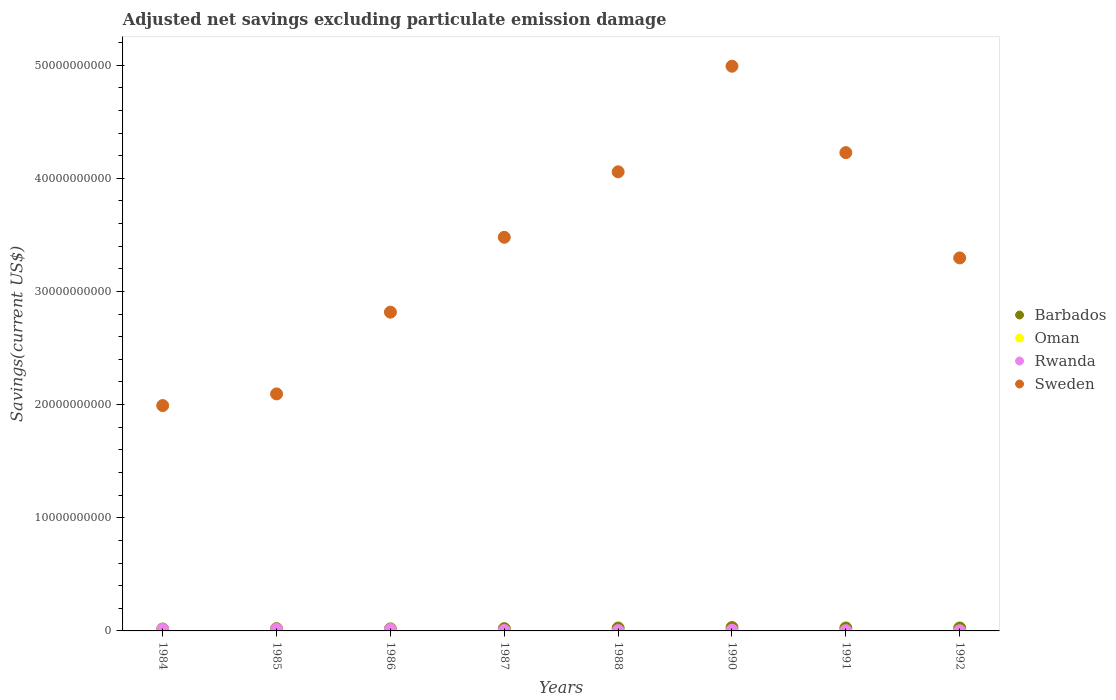How many different coloured dotlines are there?
Your answer should be compact. 4. Is the number of dotlines equal to the number of legend labels?
Offer a terse response. No. What is the adjusted net savings in Barbados in 1990?
Keep it short and to the point. 2.99e+08. Across all years, what is the maximum adjusted net savings in Oman?
Give a very brief answer. 1.23e+06. Across all years, what is the minimum adjusted net savings in Barbados?
Offer a terse response. 1.71e+08. What is the total adjusted net savings in Sweden in the graph?
Your answer should be compact. 2.70e+11. What is the difference between the adjusted net savings in Barbados in 1984 and that in 1991?
Offer a terse response. -9.13e+07. What is the difference between the adjusted net savings in Sweden in 1988 and the adjusted net savings in Rwanda in 1987?
Offer a very short reply. 4.05e+1. What is the average adjusted net savings in Oman per year?
Make the answer very short. 1.54e+05. In the year 1986, what is the difference between the adjusted net savings in Barbados and adjusted net savings in Rwanda?
Offer a terse response. 5.23e+07. In how many years, is the adjusted net savings in Oman greater than 32000000000 US$?
Provide a succinct answer. 0. What is the ratio of the adjusted net savings in Rwanda in 1987 to that in 1992?
Make the answer very short. 2.24. Is the adjusted net savings in Barbados in 1990 less than that in 1992?
Provide a short and direct response. No. Is the difference between the adjusted net savings in Barbados in 1984 and 1992 greater than the difference between the adjusted net savings in Rwanda in 1984 and 1992?
Keep it short and to the point. No. What is the difference between the highest and the second highest adjusted net savings in Barbados?
Your response must be concise. 3.71e+07. What is the difference between the highest and the lowest adjusted net savings in Sweden?
Your response must be concise. 3.00e+1. Is the sum of the adjusted net savings in Barbados in 1984 and 1985 greater than the maximum adjusted net savings in Oman across all years?
Give a very brief answer. Yes. Does the adjusted net savings in Sweden monotonically increase over the years?
Make the answer very short. No. Is the adjusted net savings in Oman strictly less than the adjusted net savings in Rwanda over the years?
Provide a succinct answer. Yes. What is the difference between two consecutive major ticks on the Y-axis?
Offer a terse response. 1.00e+1. Does the graph contain any zero values?
Make the answer very short. Yes. Does the graph contain grids?
Make the answer very short. No. How are the legend labels stacked?
Provide a succinct answer. Vertical. What is the title of the graph?
Provide a succinct answer. Adjusted net savings excluding particulate emission damage. What is the label or title of the X-axis?
Ensure brevity in your answer.  Years. What is the label or title of the Y-axis?
Your response must be concise. Savings(current US$). What is the Savings(current US$) in Barbados in 1984?
Give a very brief answer. 1.71e+08. What is the Savings(current US$) in Oman in 1984?
Provide a succinct answer. 1.23e+06. What is the Savings(current US$) in Rwanda in 1984?
Offer a very short reply. 1.42e+08. What is the Savings(current US$) in Sweden in 1984?
Your response must be concise. 1.99e+1. What is the Savings(current US$) in Barbados in 1985?
Ensure brevity in your answer.  2.02e+08. What is the Savings(current US$) in Rwanda in 1985?
Offer a terse response. 1.50e+08. What is the Savings(current US$) of Sweden in 1985?
Your response must be concise. 2.09e+1. What is the Savings(current US$) in Barbados in 1986?
Offer a terse response. 1.79e+08. What is the Savings(current US$) in Oman in 1986?
Your answer should be very brief. 0. What is the Savings(current US$) of Rwanda in 1986?
Your answer should be compact. 1.27e+08. What is the Savings(current US$) of Sweden in 1986?
Your answer should be very brief. 2.82e+1. What is the Savings(current US$) in Barbados in 1987?
Make the answer very short. 2.01e+08. What is the Savings(current US$) of Rwanda in 1987?
Offer a terse response. 3.83e+07. What is the Savings(current US$) of Sweden in 1987?
Make the answer very short. 3.48e+1. What is the Savings(current US$) in Barbados in 1988?
Your response must be concise. 2.58e+08. What is the Savings(current US$) in Oman in 1988?
Offer a terse response. 0. What is the Savings(current US$) of Rwanda in 1988?
Your response must be concise. 2.87e+07. What is the Savings(current US$) of Sweden in 1988?
Offer a very short reply. 4.06e+1. What is the Savings(current US$) in Barbados in 1990?
Provide a short and direct response. 2.99e+08. What is the Savings(current US$) in Rwanda in 1990?
Ensure brevity in your answer.  6.31e+07. What is the Savings(current US$) of Sweden in 1990?
Make the answer very short. 4.99e+1. What is the Savings(current US$) of Barbados in 1991?
Provide a succinct answer. 2.62e+08. What is the Savings(current US$) in Rwanda in 1991?
Offer a very short reply. 2.37e+07. What is the Savings(current US$) in Sweden in 1991?
Offer a terse response. 4.23e+1. What is the Savings(current US$) in Barbados in 1992?
Make the answer very short. 2.60e+08. What is the Savings(current US$) in Rwanda in 1992?
Offer a very short reply. 1.71e+07. What is the Savings(current US$) in Sweden in 1992?
Give a very brief answer. 3.30e+1. Across all years, what is the maximum Savings(current US$) of Barbados?
Offer a terse response. 2.99e+08. Across all years, what is the maximum Savings(current US$) in Oman?
Your response must be concise. 1.23e+06. Across all years, what is the maximum Savings(current US$) in Rwanda?
Ensure brevity in your answer.  1.50e+08. Across all years, what is the maximum Savings(current US$) in Sweden?
Ensure brevity in your answer.  4.99e+1. Across all years, what is the minimum Savings(current US$) in Barbados?
Ensure brevity in your answer.  1.71e+08. Across all years, what is the minimum Savings(current US$) of Oman?
Offer a very short reply. 0. Across all years, what is the minimum Savings(current US$) of Rwanda?
Your answer should be compact. 1.71e+07. Across all years, what is the minimum Savings(current US$) in Sweden?
Provide a succinct answer. 1.99e+1. What is the total Savings(current US$) of Barbados in the graph?
Make the answer very short. 1.83e+09. What is the total Savings(current US$) of Oman in the graph?
Your answer should be compact. 1.23e+06. What is the total Savings(current US$) in Rwanda in the graph?
Offer a terse response. 5.89e+08. What is the total Savings(current US$) in Sweden in the graph?
Keep it short and to the point. 2.70e+11. What is the difference between the Savings(current US$) of Barbados in 1984 and that in 1985?
Your answer should be compact. -3.12e+07. What is the difference between the Savings(current US$) of Rwanda in 1984 and that in 1985?
Offer a terse response. -7.88e+06. What is the difference between the Savings(current US$) of Sweden in 1984 and that in 1985?
Keep it short and to the point. -1.03e+09. What is the difference between the Savings(current US$) in Barbados in 1984 and that in 1986?
Offer a terse response. -8.00e+06. What is the difference between the Savings(current US$) in Rwanda in 1984 and that in 1986?
Give a very brief answer. 1.51e+07. What is the difference between the Savings(current US$) in Sweden in 1984 and that in 1986?
Your answer should be compact. -8.25e+09. What is the difference between the Savings(current US$) of Barbados in 1984 and that in 1987?
Your answer should be very brief. -2.98e+07. What is the difference between the Savings(current US$) in Rwanda in 1984 and that in 1987?
Give a very brief answer. 1.03e+08. What is the difference between the Savings(current US$) in Sweden in 1984 and that in 1987?
Your answer should be very brief. -1.49e+1. What is the difference between the Savings(current US$) of Barbados in 1984 and that in 1988?
Offer a very short reply. -8.71e+07. What is the difference between the Savings(current US$) in Rwanda in 1984 and that in 1988?
Ensure brevity in your answer.  1.13e+08. What is the difference between the Savings(current US$) in Sweden in 1984 and that in 1988?
Provide a succinct answer. -2.07e+1. What is the difference between the Savings(current US$) of Barbados in 1984 and that in 1990?
Your response must be concise. -1.28e+08. What is the difference between the Savings(current US$) of Rwanda in 1984 and that in 1990?
Give a very brief answer. 7.86e+07. What is the difference between the Savings(current US$) of Sweden in 1984 and that in 1990?
Provide a succinct answer. -3.00e+1. What is the difference between the Savings(current US$) of Barbados in 1984 and that in 1991?
Ensure brevity in your answer.  -9.13e+07. What is the difference between the Savings(current US$) of Rwanda in 1984 and that in 1991?
Your answer should be compact. 1.18e+08. What is the difference between the Savings(current US$) of Sweden in 1984 and that in 1991?
Your response must be concise. -2.24e+1. What is the difference between the Savings(current US$) in Barbados in 1984 and that in 1992?
Offer a terse response. -8.94e+07. What is the difference between the Savings(current US$) in Rwanda in 1984 and that in 1992?
Ensure brevity in your answer.  1.25e+08. What is the difference between the Savings(current US$) in Sweden in 1984 and that in 1992?
Ensure brevity in your answer.  -1.30e+1. What is the difference between the Savings(current US$) in Barbados in 1985 and that in 1986?
Offer a terse response. 2.32e+07. What is the difference between the Savings(current US$) in Rwanda in 1985 and that in 1986?
Ensure brevity in your answer.  2.30e+07. What is the difference between the Savings(current US$) in Sweden in 1985 and that in 1986?
Make the answer very short. -7.22e+09. What is the difference between the Savings(current US$) in Barbados in 1985 and that in 1987?
Ensure brevity in your answer.  1.39e+06. What is the difference between the Savings(current US$) in Rwanda in 1985 and that in 1987?
Provide a succinct answer. 1.11e+08. What is the difference between the Savings(current US$) of Sweden in 1985 and that in 1987?
Give a very brief answer. -1.38e+1. What is the difference between the Savings(current US$) in Barbados in 1985 and that in 1988?
Make the answer very short. -5.59e+07. What is the difference between the Savings(current US$) of Rwanda in 1985 and that in 1988?
Offer a terse response. 1.21e+08. What is the difference between the Savings(current US$) in Sweden in 1985 and that in 1988?
Your response must be concise. -1.96e+1. What is the difference between the Savings(current US$) in Barbados in 1985 and that in 1990?
Ensure brevity in your answer.  -9.72e+07. What is the difference between the Savings(current US$) of Rwanda in 1985 and that in 1990?
Provide a succinct answer. 8.65e+07. What is the difference between the Savings(current US$) in Sweden in 1985 and that in 1990?
Offer a terse response. -2.90e+1. What is the difference between the Savings(current US$) in Barbados in 1985 and that in 1991?
Make the answer very short. -6.01e+07. What is the difference between the Savings(current US$) in Rwanda in 1985 and that in 1991?
Keep it short and to the point. 1.26e+08. What is the difference between the Savings(current US$) in Sweden in 1985 and that in 1991?
Your answer should be very brief. -2.13e+1. What is the difference between the Savings(current US$) of Barbados in 1985 and that in 1992?
Offer a very short reply. -5.82e+07. What is the difference between the Savings(current US$) in Rwanda in 1985 and that in 1992?
Make the answer very short. 1.33e+08. What is the difference between the Savings(current US$) of Sweden in 1985 and that in 1992?
Ensure brevity in your answer.  -1.20e+1. What is the difference between the Savings(current US$) of Barbados in 1986 and that in 1987?
Ensure brevity in your answer.  -2.18e+07. What is the difference between the Savings(current US$) in Rwanda in 1986 and that in 1987?
Provide a succinct answer. 8.84e+07. What is the difference between the Savings(current US$) in Sweden in 1986 and that in 1987?
Your answer should be very brief. -6.62e+09. What is the difference between the Savings(current US$) of Barbados in 1986 and that in 1988?
Offer a very short reply. -7.91e+07. What is the difference between the Savings(current US$) of Rwanda in 1986 and that in 1988?
Your answer should be compact. 9.80e+07. What is the difference between the Savings(current US$) of Sweden in 1986 and that in 1988?
Offer a terse response. -1.24e+1. What is the difference between the Savings(current US$) of Barbados in 1986 and that in 1990?
Provide a succinct answer. -1.20e+08. What is the difference between the Savings(current US$) in Rwanda in 1986 and that in 1990?
Provide a succinct answer. 6.35e+07. What is the difference between the Savings(current US$) of Sweden in 1986 and that in 1990?
Your answer should be very brief. -2.17e+1. What is the difference between the Savings(current US$) of Barbados in 1986 and that in 1991?
Ensure brevity in your answer.  -8.33e+07. What is the difference between the Savings(current US$) of Rwanda in 1986 and that in 1991?
Provide a short and direct response. 1.03e+08. What is the difference between the Savings(current US$) of Sweden in 1986 and that in 1991?
Offer a terse response. -1.41e+1. What is the difference between the Savings(current US$) of Barbados in 1986 and that in 1992?
Your answer should be very brief. -8.14e+07. What is the difference between the Savings(current US$) of Rwanda in 1986 and that in 1992?
Your answer should be very brief. 1.10e+08. What is the difference between the Savings(current US$) of Sweden in 1986 and that in 1992?
Offer a very short reply. -4.79e+09. What is the difference between the Savings(current US$) of Barbados in 1987 and that in 1988?
Offer a terse response. -5.73e+07. What is the difference between the Savings(current US$) of Rwanda in 1987 and that in 1988?
Offer a terse response. 9.61e+06. What is the difference between the Savings(current US$) of Sweden in 1987 and that in 1988?
Your answer should be very brief. -5.79e+09. What is the difference between the Savings(current US$) of Barbados in 1987 and that in 1990?
Your response must be concise. -9.86e+07. What is the difference between the Savings(current US$) of Rwanda in 1987 and that in 1990?
Keep it short and to the point. -2.48e+07. What is the difference between the Savings(current US$) of Sweden in 1987 and that in 1990?
Your answer should be very brief. -1.51e+1. What is the difference between the Savings(current US$) of Barbados in 1987 and that in 1991?
Your answer should be very brief. -6.15e+07. What is the difference between the Savings(current US$) in Rwanda in 1987 and that in 1991?
Your response must be concise. 1.46e+07. What is the difference between the Savings(current US$) of Sweden in 1987 and that in 1991?
Offer a very short reply. -7.48e+09. What is the difference between the Savings(current US$) in Barbados in 1987 and that in 1992?
Your answer should be compact. -5.96e+07. What is the difference between the Savings(current US$) of Rwanda in 1987 and that in 1992?
Your answer should be very brief. 2.12e+07. What is the difference between the Savings(current US$) in Sweden in 1987 and that in 1992?
Give a very brief answer. 1.82e+09. What is the difference between the Savings(current US$) of Barbados in 1988 and that in 1990?
Your answer should be compact. -4.13e+07. What is the difference between the Savings(current US$) of Rwanda in 1988 and that in 1990?
Make the answer very short. -3.45e+07. What is the difference between the Savings(current US$) in Sweden in 1988 and that in 1990?
Keep it short and to the point. -9.33e+09. What is the difference between the Savings(current US$) in Barbados in 1988 and that in 1991?
Your answer should be very brief. -4.21e+06. What is the difference between the Savings(current US$) in Rwanda in 1988 and that in 1991?
Provide a succinct answer. 5.02e+06. What is the difference between the Savings(current US$) in Sweden in 1988 and that in 1991?
Offer a very short reply. -1.70e+09. What is the difference between the Savings(current US$) in Barbados in 1988 and that in 1992?
Make the answer very short. -2.31e+06. What is the difference between the Savings(current US$) of Rwanda in 1988 and that in 1992?
Offer a very short reply. 1.16e+07. What is the difference between the Savings(current US$) in Sweden in 1988 and that in 1992?
Your answer should be very brief. 7.61e+09. What is the difference between the Savings(current US$) of Barbados in 1990 and that in 1991?
Make the answer very short. 3.71e+07. What is the difference between the Savings(current US$) of Rwanda in 1990 and that in 1991?
Your answer should be very brief. 3.95e+07. What is the difference between the Savings(current US$) of Sweden in 1990 and that in 1991?
Your response must be concise. 7.64e+09. What is the difference between the Savings(current US$) of Barbados in 1990 and that in 1992?
Your response must be concise. 3.90e+07. What is the difference between the Savings(current US$) of Rwanda in 1990 and that in 1992?
Provide a succinct answer. 4.60e+07. What is the difference between the Savings(current US$) in Sweden in 1990 and that in 1992?
Keep it short and to the point. 1.69e+1. What is the difference between the Savings(current US$) of Barbados in 1991 and that in 1992?
Offer a very short reply. 1.89e+06. What is the difference between the Savings(current US$) of Rwanda in 1991 and that in 1992?
Provide a short and direct response. 6.56e+06. What is the difference between the Savings(current US$) of Sweden in 1991 and that in 1992?
Give a very brief answer. 9.31e+09. What is the difference between the Savings(current US$) of Barbados in 1984 and the Savings(current US$) of Rwanda in 1985?
Provide a short and direct response. 2.13e+07. What is the difference between the Savings(current US$) in Barbados in 1984 and the Savings(current US$) in Sweden in 1985?
Your response must be concise. -2.08e+1. What is the difference between the Savings(current US$) of Oman in 1984 and the Savings(current US$) of Rwanda in 1985?
Make the answer very short. -1.48e+08. What is the difference between the Savings(current US$) in Oman in 1984 and the Savings(current US$) in Sweden in 1985?
Give a very brief answer. -2.09e+1. What is the difference between the Savings(current US$) of Rwanda in 1984 and the Savings(current US$) of Sweden in 1985?
Offer a very short reply. -2.08e+1. What is the difference between the Savings(current US$) of Barbados in 1984 and the Savings(current US$) of Rwanda in 1986?
Your answer should be compact. 4.43e+07. What is the difference between the Savings(current US$) of Barbados in 1984 and the Savings(current US$) of Sweden in 1986?
Your answer should be very brief. -2.80e+1. What is the difference between the Savings(current US$) in Oman in 1984 and the Savings(current US$) in Rwanda in 1986?
Ensure brevity in your answer.  -1.25e+08. What is the difference between the Savings(current US$) of Oman in 1984 and the Savings(current US$) of Sweden in 1986?
Offer a terse response. -2.82e+1. What is the difference between the Savings(current US$) of Rwanda in 1984 and the Savings(current US$) of Sweden in 1986?
Keep it short and to the point. -2.80e+1. What is the difference between the Savings(current US$) of Barbados in 1984 and the Savings(current US$) of Rwanda in 1987?
Provide a succinct answer. 1.33e+08. What is the difference between the Savings(current US$) in Barbados in 1984 and the Savings(current US$) in Sweden in 1987?
Give a very brief answer. -3.46e+1. What is the difference between the Savings(current US$) of Oman in 1984 and the Savings(current US$) of Rwanda in 1987?
Your answer should be compact. -3.71e+07. What is the difference between the Savings(current US$) of Oman in 1984 and the Savings(current US$) of Sweden in 1987?
Give a very brief answer. -3.48e+1. What is the difference between the Savings(current US$) in Rwanda in 1984 and the Savings(current US$) in Sweden in 1987?
Offer a terse response. -3.46e+1. What is the difference between the Savings(current US$) of Barbados in 1984 and the Savings(current US$) of Rwanda in 1988?
Your answer should be very brief. 1.42e+08. What is the difference between the Savings(current US$) in Barbados in 1984 and the Savings(current US$) in Sweden in 1988?
Ensure brevity in your answer.  -4.04e+1. What is the difference between the Savings(current US$) in Oman in 1984 and the Savings(current US$) in Rwanda in 1988?
Provide a succinct answer. -2.75e+07. What is the difference between the Savings(current US$) in Oman in 1984 and the Savings(current US$) in Sweden in 1988?
Your response must be concise. -4.06e+1. What is the difference between the Savings(current US$) in Rwanda in 1984 and the Savings(current US$) in Sweden in 1988?
Keep it short and to the point. -4.04e+1. What is the difference between the Savings(current US$) in Barbados in 1984 and the Savings(current US$) in Rwanda in 1990?
Make the answer very short. 1.08e+08. What is the difference between the Savings(current US$) in Barbados in 1984 and the Savings(current US$) in Sweden in 1990?
Your answer should be very brief. -4.97e+1. What is the difference between the Savings(current US$) of Oman in 1984 and the Savings(current US$) of Rwanda in 1990?
Your answer should be compact. -6.19e+07. What is the difference between the Savings(current US$) in Oman in 1984 and the Savings(current US$) in Sweden in 1990?
Keep it short and to the point. -4.99e+1. What is the difference between the Savings(current US$) of Rwanda in 1984 and the Savings(current US$) of Sweden in 1990?
Offer a terse response. -4.98e+1. What is the difference between the Savings(current US$) in Barbados in 1984 and the Savings(current US$) in Rwanda in 1991?
Offer a very short reply. 1.47e+08. What is the difference between the Savings(current US$) of Barbados in 1984 and the Savings(current US$) of Sweden in 1991?
Offer a very short reply. -4.21e+1. What is the difference between the Savings(current US$) in Oman in 1984 and the Savings(current US$) in Rwanda in 1991?
Make the answer very short. -2.24e+07. What is the difference between the Savings(current US$) in Oman in 1984 and the Savings(current US$) in Sweden in 1991?
Offer a terse response. -4.23e+1. What is the difference between the Savings(current US$) in Rwanda in 1984 and the Savings(current US$) in Sweden in 1991?
Ensure brevity in your answer.  -4.21e+1. What is the difference between the Savings(current US$) in Barbados in 1984 and the Savings(current US$) in Rwanda in 1992?
Keep it short and to the point. 1.54e+08. What is the difference between the Savings(current US$) in Barbados in 1984 and the Savings(current US$) in Sweden in 1992?
Your response must be concise. -3.28e+1. What is the difference between the Savings(current US$) in Oman in 1984 and the Savings(current US$) in Rwanda in 1992?
Make the answer very short. -1.59e+07. What is the difference between the Savings(current US$) of Oman in 1984 and the Savings(current US$) of Sweden in 1992?
Keep it short and to the point. -3.30e+1. What is the difference between the Savings(current US$) in Rwanda in 1984 and the Savings(current US$) in Sweden in 1992?
Your response must be concise. -3.28e+1. What is the difference between the Savings(current US$) in Barbados in 1985 and the Savings(current US$) in Rwanda in 1986?
Offer a terse response. 7.55e+07. What is the difference between the Savings(current US$) of Barbados in 1985 and the Savings(current US$) of Sweden in 1986?
Provide a short and direct response. -2.80e+1. What is the difference between the Savings(current US$) of Rwanda in 1985 and the Savings(current US$) of Sweden in 1986?
Your response must be concise. -2.80e+1. What is the difference between the Savings(current US$) in Barbados in 1985 and the Savings(current US$) in Rwanda in 1987?
Offer a very short reply. 1.64e+08. What is the difference between the Savings(current US$) of Barbados in 1985 and the Savings(current US$) of Sweden in 1987?
Keep it short and to the point. -3.46e+1. What is the difference between the Savings(current US$) in Rwanda in 1985 and the Savings(current US$) in Sweden in 1987?
Make the answer very short. -3.46e+1. What is the difference between the Savings(current US$) in Barbados in 1985 and the Savings(current US$) in Rwanda in 1988?
Give a very brief answer. 1.73e+08. What is the difference between the Savings(current US$) of Barbados in 1985 and the Savings(current US$) of Sweden in 1988?
Your response must be concise. -4.04e+1. What is the difference between the Savings(current US$) in Rwanda in 1985 and the Savings(current US$) in Sweden in 1988?
Ensure brevity in your answer.  -4.04e+1. What is the difference between the Savings(current US$) in Barbados in 1985 and the Savings(current US$) in Rwanda in 1990?
Your answer should be very brief. 1.39e+08. What is the difference between the Savings(current US$) in Barbados in 1985 and the Savings(current US$) in Sweden in 1990?
Offer a very short reply. -4.97e+1. What is the difference between the Savings(current US$) in Rwanda in 1985 and the Savings(current US$) in Sweden in 1990?
Ensure brevity in your answer.  -4.98e+1. What is the difference between the Savings(current US$) in Barbados in 1985 and the Savings(current US$) in Rwanda in 1991?
Give a very brief answer. 1.79e+08. What is the difference between the Savings(current US$) of Barbados in 1985 and the Savings(current US$) of Sweden in 1991?
Provide a succinct answer. -4.21e+1. What is the difference between the Savings(current US$) of Rwanda in 1985 and the Savings(current US$) of Sweden in 1991?
Provide a succinct answer. -4.21e+1. What is the difference between the Savings(current US$) in Barbados in 1985 and the Savings(current US$) in Rwanda in 1992?
Offer a very short reply. 1.85e+08. What is the difference between the Savings(current US$) in Barbados in 1985 and the Savings(current US$) in Sweden in 1992?
Your answer should be very brief. -3.28e+1. What is the difference between the Savings(current US$) in Rwanda in 1985 and the Savings(current US$) in Sweden in 1992?
Keep it short and to the point. -3.28e+1. What is the difference between the Savings(current US$) of Barbados in 1986 and the Savings(current US$) of Rwanda in 1987?
Keep it short and to the point. 1.41e+08. What is the difference between the Savings(current US$) in Barbados in 1986 and the Savings(current US$) in Sweden in 1987?
Keep it short and to the point. -3.46e+1. What is the difference between the Savings(current US$) in Rwanda in 1986 and the Savings(current US$) in Sweden in 1987?
Ensure brevity in your answer.  -3.47e+1. What is the difference between the Savings(current US$) in Barbados in 1986 and the Savings(current US$) in Rwanda in 1988?
Provide a short and direct response. 1.50e+08. What is the difference between the Savings(current US$) of Barbados in 1986 and the Savings(current US$) of Sweden in 1988?
Offer a terse response. -4.04e+1. What is the difference between the Savings(current US$) of Rwanda in 1986 and the Savings(current US$) of Sweden in 1988?
Your answer should be compact. -4.04e+1. What is the difference between the Savings(current US$) in Barbados in 1986 and the Savings(current US$) in Rwanda in 1990?
Keep it short and to the point. 1.16e+08. What is the difference between the Savings(current US$) in Barbados in 1986 and the Savings(current US$) in Sweden in 1990?
Keep it short and to the point. -4.97e+1. What is the difference between the Savings(current US$) of Rwanda in 1986 and the Savings(current US$) of Sweden in 1990?
Keep it short and to the point. -4.98e+1. What is the difference between the Savings(current US$) in Barbados in 1986 and the Savings(current US$) in Rwanda in 1991?
Provide a short and direct response. 1.55e+08. What is the difference between the Savings(current US$) of Barbados in 1986 and the Savings(current US$) of Sweden in 1991?
Ensure brevity in your answer.  -4.21e+1. What is the difference between the Savings(current US$) in Rwanda in 1986 and the Savings(current US$) in Sweden in 1991?
Offer a terse response. -4.21e+1. What is the difference between the Savings(current US$) in Barbados in 1986 and the Savings(current US$) in Rwanda in 1992?
Offer a terse response. 1.62e+08. What is the difference between the Savings(current US$) of Barbados in 1986 and the Savings(current US$) of Sweden in 1992?
Offer a terse response. -3.28e+1. What is the difference between the Savings(current US$) of Rwanda in 1986 and the Savings(current US$) of Sweden in 1992?
Offer a terse response. -3.28e+1. What is the difference between the Savings(current US$) of Barbados in 1987 and the Savings(current US$) of Rwanda in 1988?
Keep it short and to the point. 1.72e+08. What is the difference between the Savings(current US$) of Barbados in 1987 and the Savings(current US$) of Sweden in 1988?
Give a very brief answer. -4.04e+1. What is the difference between the Savings(current US$) in Rwanda in 1987 and the Savings(current US$) in Sweden in 1988?
Give a very brief answer. -4.05e+1. What is the difference between the Savings(current US$) in Barbados in 1987 and the Savings(current US$) in Rwanda in 1990?
Ensure brevity in your answer.  1.38e+08. What is the difference between the Savings(current US$) of Barbados in 1987 and the Savings(current US$) of Sweden in 1990?
Make the answer very short. -4.97e+1. What is the difference between the Savings(current US$) of Rwanda in 1987 and the Savings(current US$) of Sweden in 1990?
Your answer should be compact. -4.99e+1. What is the difference between the Savings(current US$) in Barbados in 1987 and the Savings(current US$) in Rwanda in 1991?
Provide a short and direct response. 1.77e+08. What is the difference between the Savings(current US$) of Barbados in 1987 and the Savings(current US$) of Sweden in 1991?
Your response must be concise. -4.21e+1. What is the difference between the Savings(current US$) in Rwanda in 1987 and the Savings(current US$) in Sweden in 1991?
Provide a short and direct response. -4.22e+1. What is the difference between the Savings(current US$) of Barbados in 1987 and the Savings(current US$) of Rwanda in 1992?
Make the answer very short. 1.84e+08. What is the difference between the Savings(current US$) in Barbados in 1987 and the Savings(current US$) in Sweden in 1992?
Your response must be concise. -3.28e+1. What is the difference between the Savings(current US$) in Rwanda in 1987 and the Savings(current US$) in Sweden in 1992?
Your answer should be compact. -3.29e+1. What is the difference between the Savings(current US$) in Barbados in 1988 and the Savings(current US$) in Rwanda in 1990?
Your answer should be very brief. 1.95e+08. What is the difference between the Savings(current US$) of Barbados in 1988 and the Savings(current US$) of Sweden in 1990?
Your answer should be compact. -4.96e+1. What is the difference between the Savings(current US$) of Rwanda in 1988 and the Savings(current US$) of Sweden in 1990?
Make the answer very short. -4.99e+1. What is the difference between the Savings(current US$) in Barbados in 1988 and the Savings(current US$) in Rwanda in 1991?
Your answer should be very brief. 2.34e+08. What is the difference between the Savings(current US$) of Barbados in 1988 and the Savings(current US$) of Sweden in 1991?
Ensure brevity in your answer.  -4.20e+1. What is the difference between the Savings(current US$) of Rwanda in 1988 and the Savings(current US$) of Sweden in 1991?
Your answer should be compact. -4.22e+1. What is the difference between the Savings(current US$) of Barbados in 1988 and the Savings(current US$) of Rwanda in 1992?
Provide a succinct answer. 2.41e+08. What is the difference between the Savings(current US$) in Barbados in 1988 and the Savings(current US$) in Sweden in 1992?
Give a very brief answer. -3.27e+1. What is the difference between the Savings(current US$) in Rwanda in 1988 and the Savings(current US$) in Sweden in 1992?
Provide a short and direct response. -3.29e+1. What is the difference between the Savings(current US$) of Barbados in 1990 and the Savings(current US$) of Rwanda in 1991?
Your response must be concise. 2.76e+08. What is the difference between the Savings(current US$) of Barbados in 1990 and the Savings(current US$) of Sweden in 1991?
Provide a short and direct response. -4.20e+1. What is the difference between the Savings(current US$) in Rwanda in 1990 and the Savings(current US$) in Sweden in 1991?
Keep it short and to the point. -4.22e+1. What is the difference between the Savings(current US$) of Barbados in 1990 and the Savings(current US$) of Rwanda in 1992?
Provide a succinct answer. 2.82e+08. What is the difference between the Savings(current US$) in Barbados in 1990 and the Savings(current US$) in Sweden in 1992?
Provide a short and direct response. -3.27e+1. What is the difference between the Savings(current US$) in Rwanda in 1990 and the Savings(current US$) in Sweden in 1992?
Ensure brevity in your answer.  -3.29e+1. What is the difference between the Savings(current US$) of Barbados in 1991 and the Savings(current US$) of Rwanda in 1992?
Make the answer very short. 2.45e+08. What is the difference between the Savings(current US$) of Barbados in 1991 and the Savings(current US$) of Sweden in 1992?
Your response must be concise. -3.27e+1. What is the difference between the Savings(current US$) in Rwanda in 1991 and the Savings(current US$) in Sweden in 1992?
Your response must be concise. -3.29e+1. What is the average Savings(current US$) in Barbados per year?
Offer a terse response. 2.29e+08. What is the average Savings(current US$) in Oman per year?
Give a very brief answer. 1.54e+05. What is the average Savings(current US$) of Rwanda per year?
Keep it short and to the point. 7.36e+07. What is the average Savings(current US$) in Sweden per year?
Your response must be concise. 3.37e+1. In the year 1984, what is the difference between the Savings(current US$) in Barbados and Savings(current US$) in Oman?
Offer a very short reply. 1.70e+08. In the year 1984, what is the difference between the Savings(current US$) of Barbados and Savings(current US$) of Rwanda?
Your answer should be compact. 2.92e+07. In the year 1984, what is the difference between the Savings(current US$) of Barbados and Savings(current US$) of Sweden?
Provide a short and direct response. -1.97e+1. In the year 1984, what is the difference between the Savings(current US$) of Oman and Savings(current US$) of Rwanda?
Give a very brief answer. -1.40e+08. In the year 1984, what is the difference between the Savings(current US$) of Oman and Savings(current US$) of Sweden?
Offer a terse response. -1.99e+1. In the year 1984, what is the difference between the Savings(current US$) of Rwanda and Savings(current US$) of Sweden?
Ensure brevity in your answer.  -1.98e+1. In the year 1985, what is the difference between the Savings(current US$) of Barbados and Savings(current US$) of Rwanda?
Give a very brief answer. 5.26e+07. In the year 1985, what is the difference between the Savings(current US$) of Barbados and Savings(current US$) of Sweden?
Your answer should be very brief. -2.07e+1. In the year 1985, what is the difference between the Savings(current US$) in Rwanda and Savings(current US$) in Sweden?
Your answer should be compact. -2.08e+1. In the year 1986, what is the difference between the Savings(current US$) of Barbados and Savings(current US$) of Rwanda?
Provide a short and direct response. 5.23e+07. In the year 1986, what is the difference between the Savings(current US$) of Barbados and Savings(current US$) of Sweden?
Your answer should be very brief. -2.80e+1. In the year 1986, what is the difference between the Savings(current US$) in Rwanda and Savings(current US$) in Sweden?
Make the answer very short. -2.80e+1. In the year 1987, what is the difference between the Savings(current US$) of Barbados and Savings(current US$) of Rwanda?
Your response must be concise. 1.62e+08. In the year 1987, what is the difference between the Savings(current US$) of Barbados and Savings(current US$) of Sweden?
Make the answer very short. -3.46e+1. In the year 1987, what is the difference between the Savings(current US$) in Rwanda and Savings(current US$) in Sweden?
Make the answer very short. -3.48e+1. In the year 1988, what is the difference between the Savings(current US$) in Barbados and Savings(current US$) in Rwanda?
Ensure brevity in your answer.  2.29e+08. In the year 1988, what is the difference between the Savings(current US$) in Barbados and Savings(current US$) in Sweden?
Your response must be concise. -4.03e+1. In the year 1988, what is the difference between the Savings(current US$) of Rwanda and Savings(current US$) of Sweden?
Your answer should be compact. -4.05e+1. In the year 1990, what is the difference between the Savings(current US$) in Barbados and Savings(current US$) in Rwanda?
Give a very brief answer. 2.36e+08. In the year 1990, what is the difference between the Savings(current US$) in Barbados and Savings(current US$) in Sweden?
Provide a short and direct response. -4.96e+1. In the year 1990, what is the difference between the Savings(current US$) of Rwanda and Savings(current US$) of Sweden?
Your answer should be very brief. -4.98e+1. In the year 1991, what is the difference between the Savings(current US$) in Barbados and Savings(current US$) in Rwanda?
Provide a succinct answer. 2.39e+08. In the year 1991, what is the difference between the Savings(current US$) of Barbados and Savings(current US$) of Sweden?
Keep it short and to the point. -4.20e+1. In the year 1991, what is the difference between the Savings(current US$) in Rwanda and Savings(current US$) in Sweden?
Offer a terse response. -4.22e+1. In the year 1992, what is the difference between the Savings(current US$) of Barbados and Savings(current US$) of Rwanda?
Offer a terse response. 2.43e+08. In the year 1992, what is the difference between the Savings(current US$) in Barbados and Savings(current US$) in Sweden?
Provide a short and direct response. -3.27e+1. In the year 1992, what is the difference between the Savings(current US$) in Rwanda and Savings(current US$) in Sweden?
Your response must be concise. -3.29e+1. What is the ratio of the Savings(current US$) in Barbados in 1984 to that in 1985?
Your answer should be very brief. 0.85. What is the ratio of the Savings(current US$) of Rwanda in 1984 to that in 1985?
Make the answer very short. 0.95. What is the ratio of the Savings(current US$) of Sweden in 1984 to that in 1985?
Offer a terse response. 0.95. What is the ratio of the Savings(current US$) in Barbados in 1984 to that in 1986?
Your response must be concise. 0.96. What is the ratio of the Savings(current US$) in Rwanda in 1984 to that in 1986?
Make the answer very short. 1.12. What is the ratio of the Savings(current US$) of Sweden in 1984 to that in 1986?
Provide a short and direct response. 0.71. What is the ratio of the Savings(current US$) in Barbados in 1984 to that in 1987?
Keep it short and to the point. 0.85. What is the ratio of the Savings(current US$) in Rwanda in 1984 to that in 1987?
Your answer should be compact. 3.7. What is the ratio of the Savings(current US$) of Sweden in 1984 to that in 1987?
Your answer should be very brief. 0.57. What is the ratio of the Savings(current US$) in Barbados in 1984 to that in 1988?
Offer a terse response. 0.66. What is the ratio of the Savings(current US$) of Rwanda in 1984 to that in 1988?
Give a very brief answer. 4.94. What is the ratio of the Savings(current US$) of Sweden in 1984 to that in 1988?
Make the answer very short. 0.49. What is the ratio of the Savings(current US$) of Barbados in 1984 to that in 1990?
Make the answer very short. 0.57. What is the ratio of the Savings(current US$) in Rwanda in 1984 to that in 1990?
Offer a terse response. 2.24. What is the ratio of the Savings(current US$) of Sweden in 1984 to that in 1990?
Make the answer very short. 0.4. What is the ratio of the Savings(current US$) of Barbados in 1984 to that in 1991?
Offer a very short reply. 0.65. What is the ratio of the Savings(current US$) in Rwanda in 1984 to that in 1991?
Keep it short and to the point. 5.99. What is the ratio of the Savings(current US$) in Sweden in 1984 to that in 1991?
Make the answer very short. 0.47. What is the ratio of the Savings(current US$) of Barbados in 1984 to that in 1992?
Provide a succinct answer. 0.66. What is the ratio of the Savings(current US$) of Rwanda in 1984 to that in 1992?
Keep it short and to the point. 8.29. What is the ratio of the Savings(current US$) in Sweden in 1984 to that in 1992?
Your response must be concise. 0.6. What is the ratio of the Savings(current US$) in Barbados in 1985 to that in 1986?
Keep it short and to the point. 1.13. What is the ratio of the Savings(current US$) in Rwanda in 1985 to that in 1986?
Give a very brief answer. 1.18. What is the ratio of the Savings(current US$) of Sweden in 1985 to that in 1986?
Provide a succinct answer. 0.74. What is the ratio of the Savings(current US$) of Barbados in 1985 to that in 1987?
Ensure brevity in your answer.  1.01. What is the ratio of the Savings(current US$) in Rwanda in 1985 to that in 1987?
Your answer should be very brief. 3.91. What is the ratio of the Savings(current US$) of Sweden in 1985 to that in 1987?
Provide a succinct answer. 0.6. What is the ratio of the Savings(current US$) in Barbados in 1985 to that in 1988?
Give a very brief answer. 0.78. What is the ratio of the Savings(current US$) in Rwanda in 1985 to that in 1988?
Your answer should be very brief. 5.22. What is the ratio of the Savings(current US$) in Sweden in 1985 to that in 1988?
Give a very brief answer. 0.52. What is the ratio of the Savings(current US$) in Barbados in 1985 to that in 1990?
Ensure brevity in your answer.  0.68. What is the ratio of the Savings(current US$) of Rwanda in 1985 to that in 1990?
Ensure brevity in your answer.  2.37. What is the ratio of the Savings(current US$) of Sweden in 1985 to that in 1990?
Your response must be concise. 0.42. What is the ratio of the Savings(current US$) of Barbados in 1985 to that in 1991?
Your response must be concise. 0.77. What is the ratio of the Savings(current US$) in Rwanda in 1985 to that in 1991?
Offer a very short reply. 6.32. What is the ratio of the Savings(current US$) in Sweden in 1985 to that in 1991?
Provide a short and direct response. 0.5. What is the ratio of the Savings(current US$) of Barbados in 1985 to that in 1992?
Your answer should be compact. 0.78. What is the ratio of the Savings(current US$) of Rwanda in 1985 to that in 1992?
Make the answer very short. 8.75. What is the ratio of the Savings(current US$) of Sweden in 1985 to that in 1992?
Your answer should be compact. 0.64. What is the ratio of the Savings(current US$) of Barbados in 1986 to that in 1987?
Your response must be concise. 0.89. What is the ratio of the Savings(current US$) of Rwanda in 1986 to that in 1987?
Provide a succinct answer. 3.31. What is the ratio of the Savings(current US$) of Sweden in 1986 to that in 1987?
Your response must be concise. 0.81. What is the ratio of the Savings(current US$) in Barbados in 1986 to that in 1988?
Your answer should be compact. 0.69. What is the ratio of the Savings(current US$) of Rwanda in 1986 to that in 1988?
Your answer should be compact. 4.42. What is the ratio of the Savings(current US$) in Sweden in 1986 to that in 1988?
Your answer should be very brief. 0.69. What is the ratio of the Savings(current US$) in Barbados in 1986 to that in 1990?
Provide a succinct answer. 0.6. What is the ratio of the Savings(current US$) of Rwanda in 1986 to that in 1990?
Ensure brevity in your answer.  2.01. What is the ratio of the Savings(current US$) of Sweden in 1986 to that in 1990?
Offer a very short reply. 0.56. What is the ratio of the Savings(current US$) in Barbados in 1986 to that in 1991?
Give a very brief answer. 0.68. What is the ratio of the Savings(current US$) of Rwanda in 1986 to that in 1991?
Give a very brief answer. 5.35. What is the ratio of the Savings(current US$) of Sweden in 1986 to that in 1991?
Keep it short and to the point. 0.67. What is the ratio of the Savings(current US$) of Barbados in 1986 to that in 1992?
Give a very brief answer. 0.69. What is the ratio of the Savings(current US$) of Rwanda in 1986 to that in 1992?
Your answer should be compact. 7.4. What is the ratio of the Savings(current US$) of Sweden in 1986 to that in 1992?
Provide a short and direct response. 0.85. What is the ratio of the Savings(current US$) in Barbados in 1987 to that in 1988?
Your answer should be compact. 0.78. What is the ratio of the Savings(current US$) of Rwanda in 1987 to that in 1988?
Your response must be concise. 1.34. What is the ratio of the Savings(current US$) in Sweden in 1987 to that in 1988?
Your answer should be compact. 0.86. What is the ratio of the Savings(current US$) in Barbados in 1987 to that in 1990?
Ensure brevity in your answer.  0.67. What is the ratio of the Savings(current US$) in Rwanda in 1987 to that in 1990?
Your answer should be very brief. 0.61. What is the ratio of the Savings(current US$) of Sweden in 1987 to that in 1990?
Give a very brief answer. 0.7. What is the ratio of the Savings(current US$) of Barbados in 1987 to that in 1991?
Provide a succinct answer. 0.77. What is the ratio of the Savings(current US$) in Rwanda in 1987 to that in 1991?
Provide a short and direct response. 1.62. What is the ratio of the Savings(current US$) of Sweden in 1987 to that in 1991?
Ensure brevity in your answer.  0.82. What is the ratio of the Savings(current US$) of Barbados in 1987 to that in 1992?
Give a very brief answer. 0.77. What is the ratio of the Savings(current US$) in Rwanda in 1987 to that in 1992?
Give a very brief answer. 2.24. What is the ratio of the Savings(current US$) in Sweden in 1987 to that in 1992?
Offer a terse response. 1.06. What is the ratio of the Savings(current US$) of Barbados in 1988 to that in 1990?
Ensure brevity in your answer.  0.86. What is the ratio of the Savings(current US$) in Rwanda in 1988 to that in 1990?
Provide a succinct answer. 0.45. What is the ratio of the Savings(current US$) of Sweden in 1988 to that in 1990?
Keep it short and to the point. 0.81. What is the ratio of the Savings(current US$) in Rwanda in 1988 to that in 1991?
Your answer should be compact. 1.21. What is the ratio of the Savings(current US$) in Sweden in 1988 to that in 1991?
Make the answer very short. 0.96. What is the ratio of the Savings(current US$) of Barbados in 1988 to that in 1992?
Provide a short and direct response. 0.99. What is the ratio of the Savings(current US$) of Rwanda in 1988 to that in 1992?
Offer a very short reply. 1.68. What is the ratio of the Savings(current US$) in Sweden in 1988 to that in 1992?
Offer a very short reply. 1.23. What is the ratio of the Savings(current US$) in Barbados in 1990 to that in 1991?
Your answer should be compact. 1.14. What is the ratio of the Savings(current US$) in Rwanda in 1990 to that in 1991?
Provide a short and direct response. 2.67. What is the ratio of the Savings(current US$) in Sweden in 1990 to that in 1991?
Offer a very short reply. 1.18. What is the ratio of the Savings(current US$) of Barbados in 1990 to that in 1992?
Your answer should be compact. 1.15. What is the ratio of the Savings(current US$) of Rwanda in 1990 to that in 1992?
Give a very brief answer. 3.69. What is the ratio of the Savings(current US$) in Sweden in 1990 to that in 1992?
Offer a very short reply. 1.51. What is the ratio of the Savings(current US$) in Barbados in 1991 to that in 1992?
Your answer should be compact. 1.01. What is the ratio of the Savings(current US$) in Rwanda in 1991 to that in 1992?
Give a very brief answer. 1.38. What is the ratio of the Savings(current US$) in Sweden in 1991 to that in 1992?
Offer a very short reply. 1.28. What is the difference between the highest and the second highest Savings(current US$) in Barbados?
Provide a succinct answer. 3.71e+07. What is the difference between the highest and the second highest Savings(current US$) of Rwanda?
Keep it short and to the point. 7.88e+06. What is the difference between the highest and the second highest Savings(current US$) of Sweden?
Your answer should be very brief. 7.64e+09. What is the difference between the highest and the lowest Savings(current US$) in Barbados?
Your answer should be very brief. 1.28e+08. What is the difference between the highest and the lowest Savings(current US$) in Oman?
Ensure brevity in your answer.  1.23e+06. What is the difference between the highest and the lowest Savings(current US$) in Rwanda?
Ensure brevity in your answer.  1.33e+08. What is the difference between the highest and the lowest Savings(current US$) in Sweden?
Ensure brevity in your answer.  3.00e+1. 